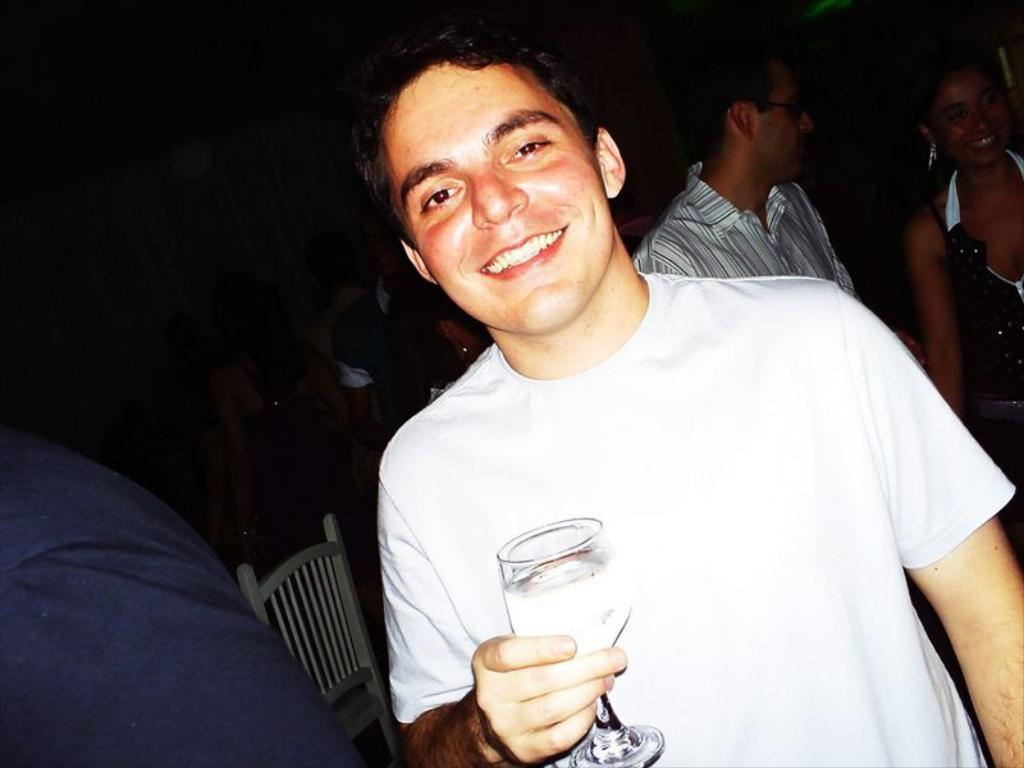Who is present in the image? There is a person in the image. What is the person holding in his hand? The person is holding a glass in his hand. What can be seen in the background of the image? There are people and a chair in the background of the image. What type of steel is being used to cook on the stove in the image? There is no stove or steel present in the image. What is the tax rate for the area depicted in the image? The image does not provide any information about the tax rate for the area. 